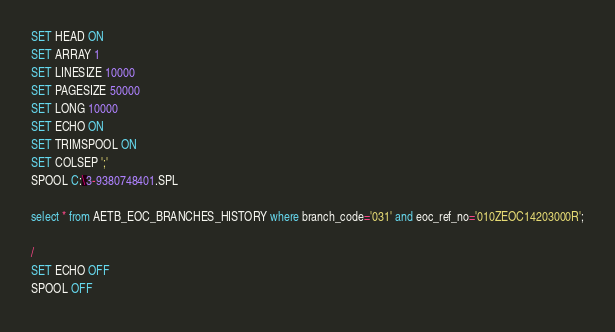Convert code to text. <code><loc_0><loc_0><loc_500><loc_500><_SQL_>SET HEAD ON
SET ARRAY 1
SET LINESIZE 10000
SET PAGESIZE 50000
SET LONG 10000
SET ECHO ON
SET TRIMSPOOL ON
SET COLSEP ';'
SPOOL C:\3-9380748401.SPL

select * from AETB_EOC_BRANCHES_HISTORY where branch_code='031' and eoc_ref_no='010ZEOC14203000R';

/
SET ECHO OFF
SPOOL OFF</code> 